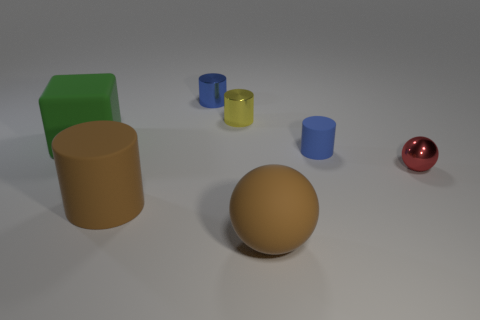Subtract all gray cylinders. Subtract all cyan spheres. How many cylinders are left? 4 Add 1 big objects. How many objects exist? 8 Subtract all blocks. How many objects are left? 6 Add 5 large objects. How many large objects exist? 8 Subtract 0 cyan blocks. How many objects are left? 7 Subtract all large cubes. Subtract all small red things. How many objects are left? 5 Add 7 small yellow shiny things. How many small yellow shiny things are left? 8 